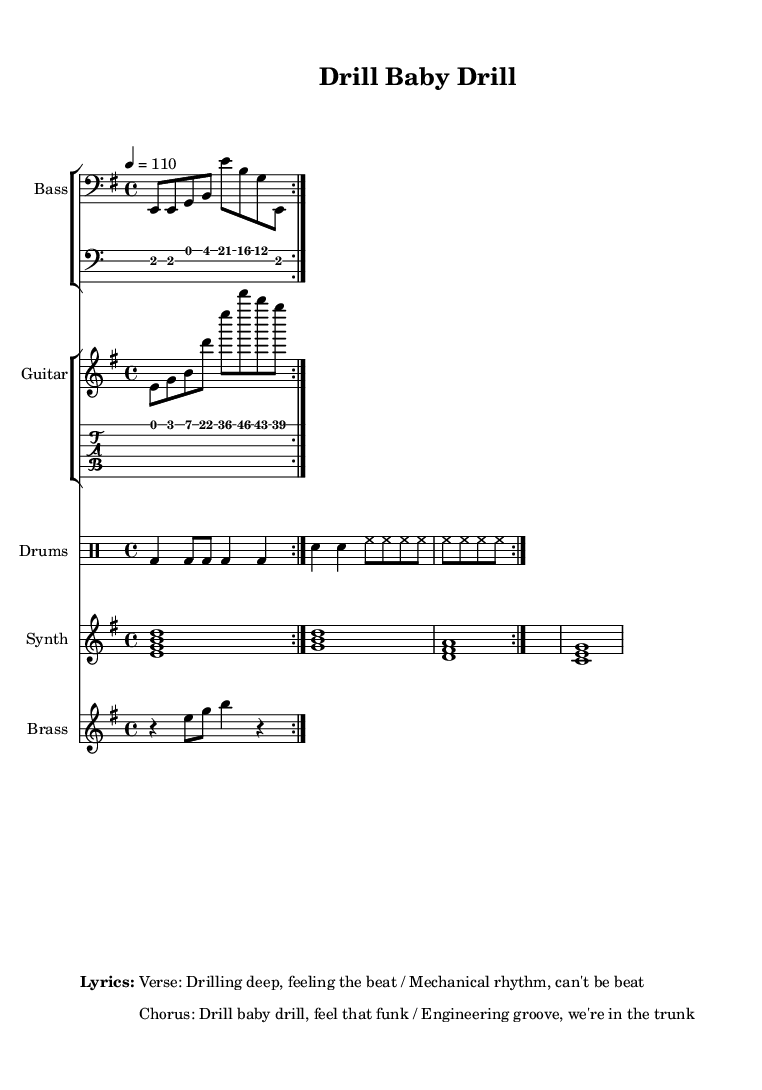What is the key signature of this music? The key signature shown in the music is E minor, which typically contains one sharp (F#). This is indicated by the placement of the sharp on the staff at the beginning of the piece.
Answer: E minor What is the time signature of this music? The time signature is 4/4, which is visible at the beginning of the score. This means there are four beats in each measure and the quarter note gets one beat.
Answer: 4/4 What is the tempo marking? The tempo marking is indicated as 4 = 110, meaning there are 110 beats per minute (BPM), and each beat corresponds to a quarter note. This is typically noted at the start of the piece.
Answer: 110 How many measures are in the bass line? The bass line has a repeating section that plays twice, with each repeat consisting of four measures, leading to a total of eight measures. You can count the frets and pauses indicated to find this.
Answer: 8 measures What instrument plays the chord progression? The chord progression is played by the synth, as indicated in the score. This is shown in the staff labeled "Synth," which contains the chord symbols representing the harmony of the piece.
Answer: Synth What type of drum pattern is used? The drum pattern consists primarily of bass drum (bd), snare drum (sn), and hi-hat (hh) notations in the score. The pattern is syncopated and typical of funk music, emphasizing the backbeat.
Answer: Groove-heavy What is the theme of the lyrics? The lyrics focus on the theme of drilling, using phrases that draw a parallel between drilling operations and the energetic rhythm of funk music, thus blending the two concepts creatively.
Answer: Drilling and rhythm 